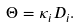<formula> <loc_0><loc_0><loc_500><loc_500>\Theta = \kappa _ { i } D _ { i } .</formula> 